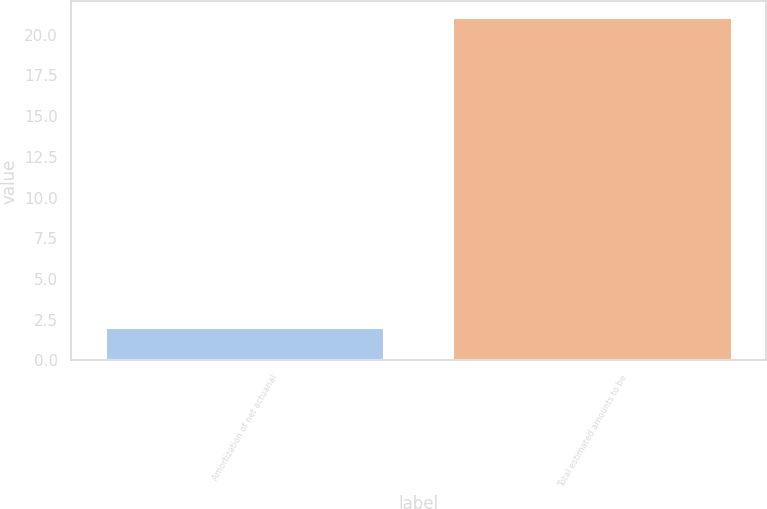<chart> <loc_0><loc_0><loc_500><loc_500><bar_chart><fcel>Amortization of net actuarial<fcel>Total estimated amounts to be<nl><fcel>2<fcel>21<nl></chart> 